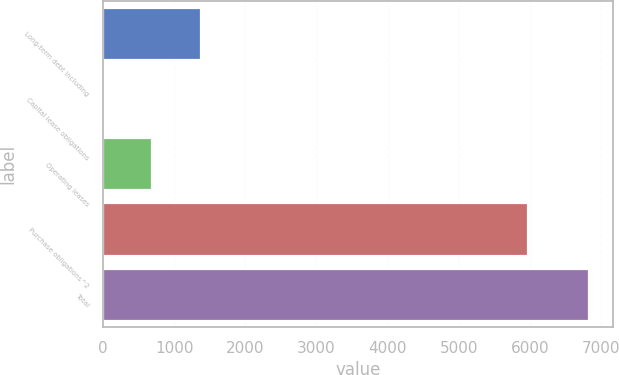Convert chart to OTSL. <chart><loc_0><loc_0><loc_500><loc_500><bar_chart><fcel>Long-term debt including<fcel>Capital lease obligations<fcel>Operating leases<fcel>Purchase obligations^2<fcel>Total<nl><fcel>1377.1<fcel>13.1<fcel>695.1<fcel>5976.3<fcel>6833.1<nl></chart> 